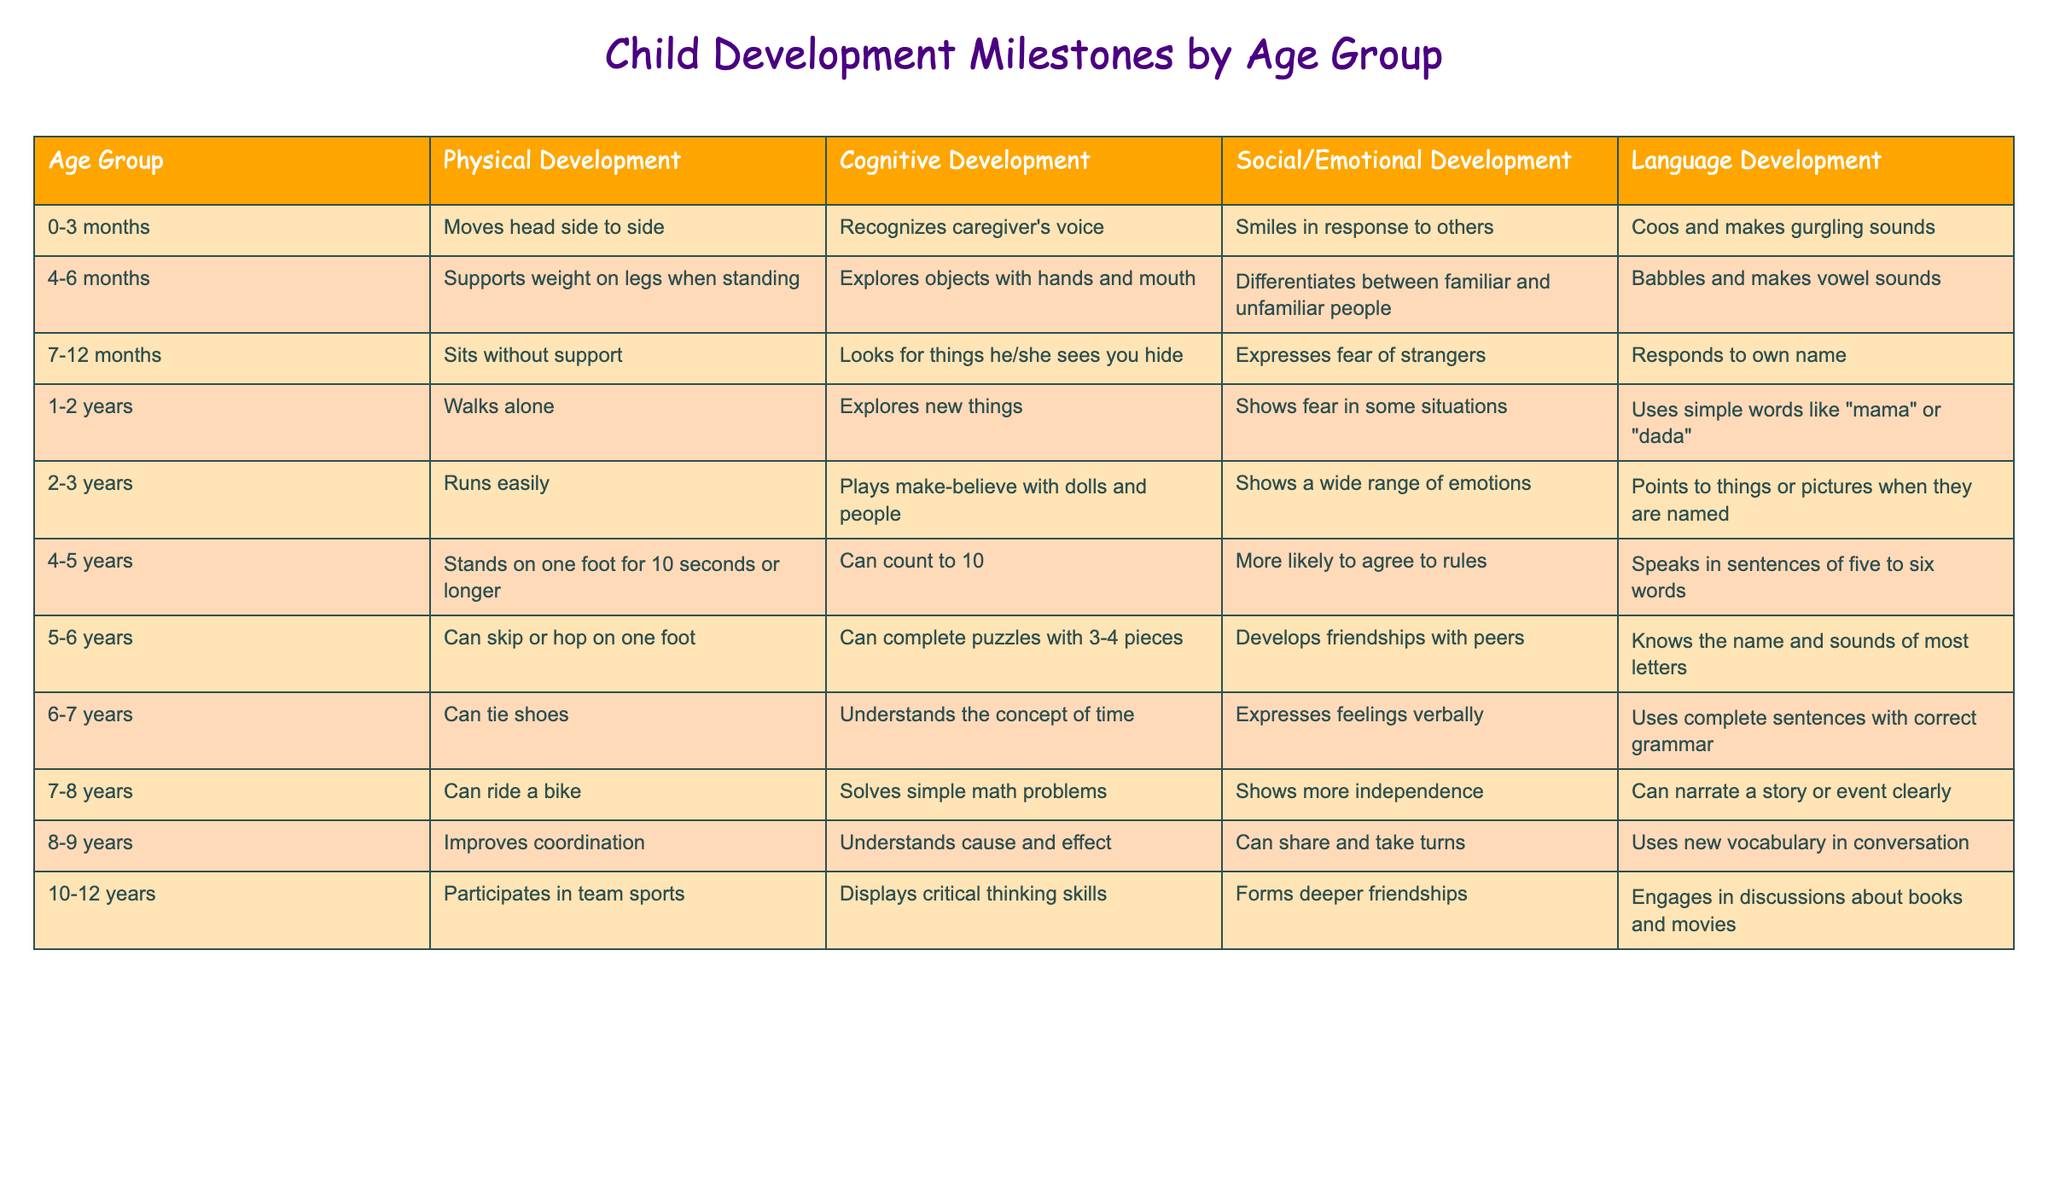What is the physical development milestone for children aged 2-3 years? The table shows that children aged 2-3 years can run easily.
Answer: Run easily What social/emotional development is observed in children aged 4-5 years? According to the table, children in this age group are more likely to agree to rules.
Answer: More likely to agree to rules Which age group begins to participate in team sports? The table indicates that children aged 10-12 years participate in team sports.
Answer: 10-12 years What is the cognitive development milestone for children aged 6-7 years? The milestone listed for this age group is understanding the concept of time.
Answer: Understands the concept of time How many developmental milestones are listed for children aged 1-2 years? The table provides four milestones for this age group: walks alone, explores new things, shows fear in some situations, and uses simple words.
Answer: Four milestones At what age do children typically start to tie their shoes? From the table, children can tie shoes at the age of 6-7 years.
Answer: 6-7 years Is it true that children aged 5-6 years can complete puzzles with 3-4 pieces? Yes, the table states that this is a milestone for children in this age group.
Answer: Yes What distinctive language skill is shown by children aged 8-9 years? The table notes that children in this age group use new vocabulary in conversation.
Answer: Uses new vocabulary What is the average age of the developmental milestones mentioned for social/emotional development across all age groups? To find the average, we'll consider the age groups (0-3, 4-6, 7-12, 1-2, 2-3, 4-5, 5-6, 6-7, 7-8, 8-9, 10-12) and split the age ranges appropriately. Achieving the average takes the midpoints of each range, summing to 6.5 and dividing by 11, yielding approximately 6.5 years.
Answer: 6.5 years Which age group shows improved coordination in physical development? The table shows that children aged 8-9 years improve coordination as a milestone.
Answer: 8-9 years What social/emotional development milestone do children aged 7-8 years achieve? Children aged 7-8 years show more independence according to the table.
Answer: Shows more independence 